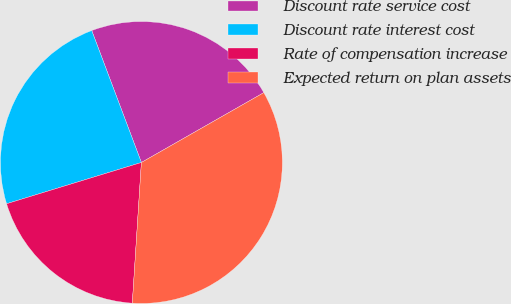<chart> <loc_0><loc_0><loc_500><loc_500><pie_chart><fcel>Discount rate service cost<fcel>Discount rate interest cost<fcel>Rate of compensation increase<fcel>Expected return on plan assets<nl><fcel>22.48%<fcel>24.0%<fcel>19.25%<fcel>34.28%<nl></chart> 